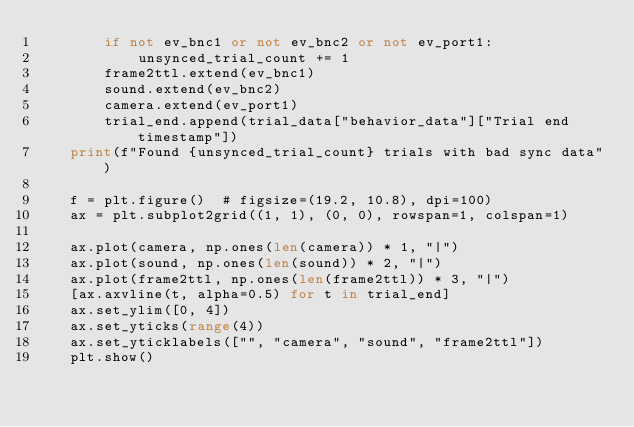Convert code to text. <code><loc_0><loc_0><loc_500><loc_500><_Python_>        if not ev_bnc1 or not ev_bnc2 or not ev_port1:
            unsynced_trial_count += 1
        frame2ttl.extend(ev_bnc1)
        sound.extend(ev_bnc2)
        camera.extend(ev_port1)
        trial_end.append(trial_data["behavior_data"]["Trial end timestamp"])
    print(f"Found {unsynced_trial_count} trials with bad sync data")

    f = plt.figure()  # figsize=(19.2, 10.8), dpi=100)
    ax = plt.subplot2grid((1, 1), (0, 0), rowspan=1, colspan=1)

    ax.plot(camera, np.ones(len(camera)) * 1, "|")
    ax.plot(sound, np.ones(len(sound)) * 2, "|")
    ax.plot(frame2ttl, np.ones(len(frame2ttl)) * 3, "|")
    [ax.axvline(t, alpha=0.5) for t in trial_end]
    ax.set_ylim([0, 4])
    ax.set_yticks(range(4))
    ax.set_yticklabels(["", "camera", "sound", "frame2ttl"])
    plt.show()
</code> 